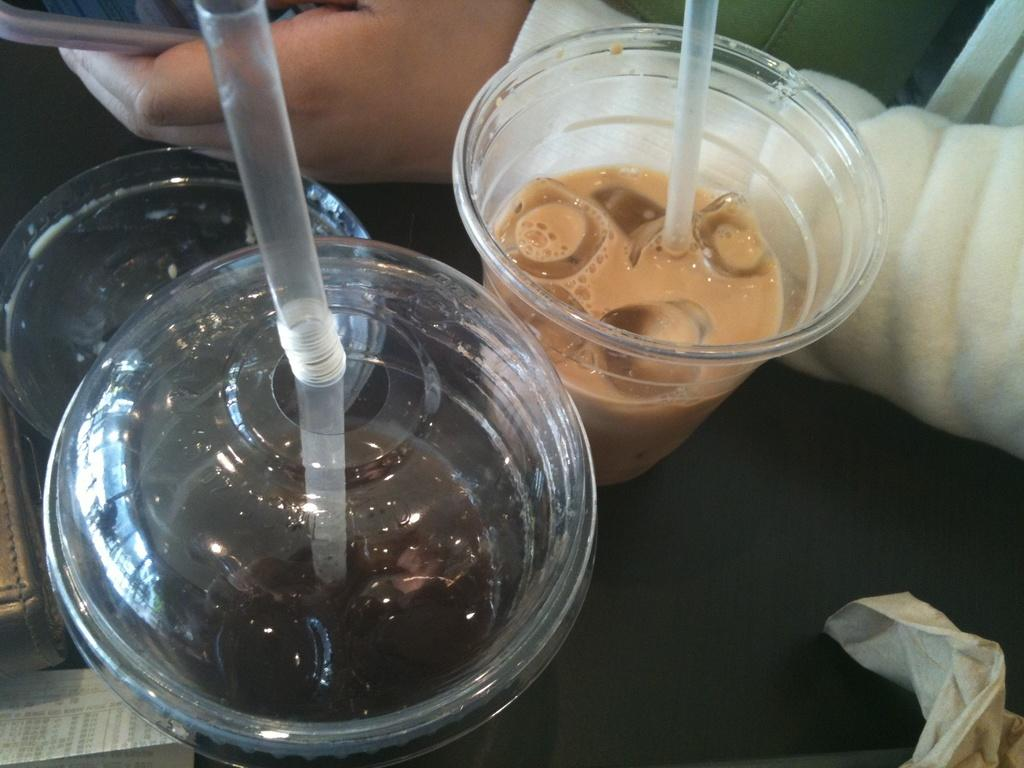What is on the table in the image? There are cups of drinks on a table in the image. What can be used to drink the contents of the cups? There are straws in the cups. What can be seen in the background of the image? A hand holding a phone is visible in the background. What item might be used for cleaning or wiping in the image? There is a tissue present. What type of holiday is being celebrated in the image? There is no indication of a holiday being celebrated in the image. What government policy is being discussed in the image? There is no discussion of government policy in the image. 